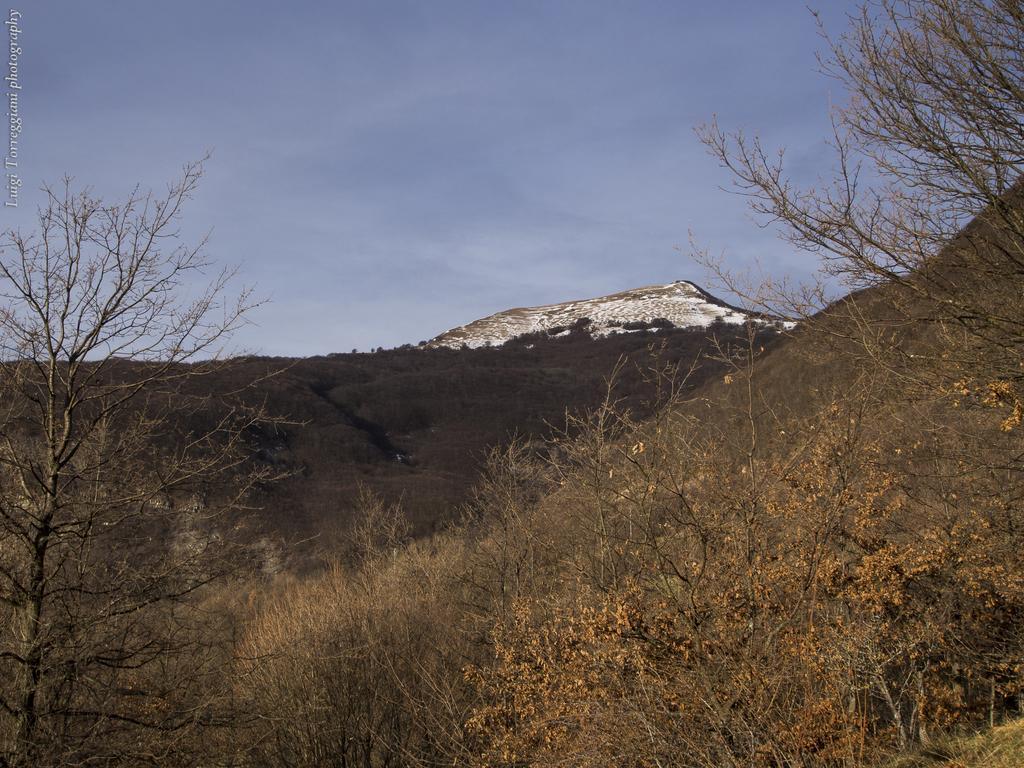How would you summarize this image in a sentence or two? At the bottom of this image, there are trees on a hill. In the background, there are mountains and there are clouds in the blue sky. 